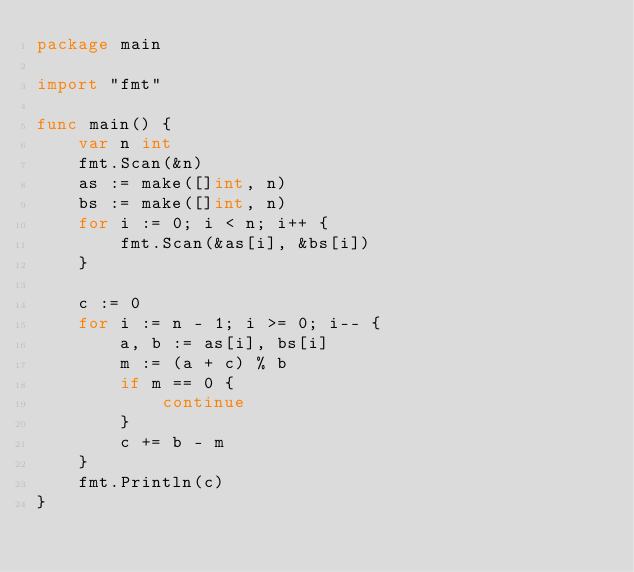Convert code to text. <code><loc_0><loc_0><loc_500><loc_500><_Go_>package main

import "fmt"

func main() {
	var n int
	fmt.Scan(&n)
	as := make([]int, n)
	bs := make([]int, n)
	for i := 0; i < n; i++ {
		fmt.Scan(&as[i], &bs[i])
	}

	c := 0
	for i := n - 1; i >= 0; i-- {
		a, b := as[i], bs[i]
		m := (a + c) % b
		if m == 0 {
			continue
		}
		c += b - m
	}
	fmt.Println(c)
}
</code> 